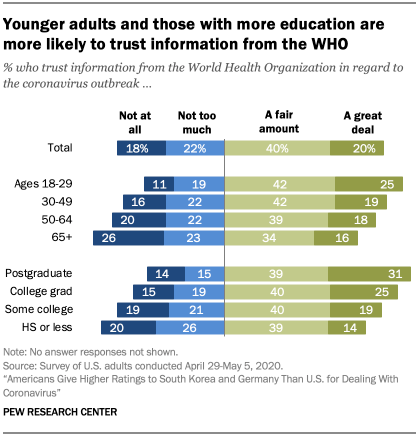Give some essential details in this illustration. The median value of "A fair amount" bars is 40. A recent survey found that a great majority, approximately 80%, of the 65+ age group trust the World Health Organization (WHO) in regard to health-related matters. 